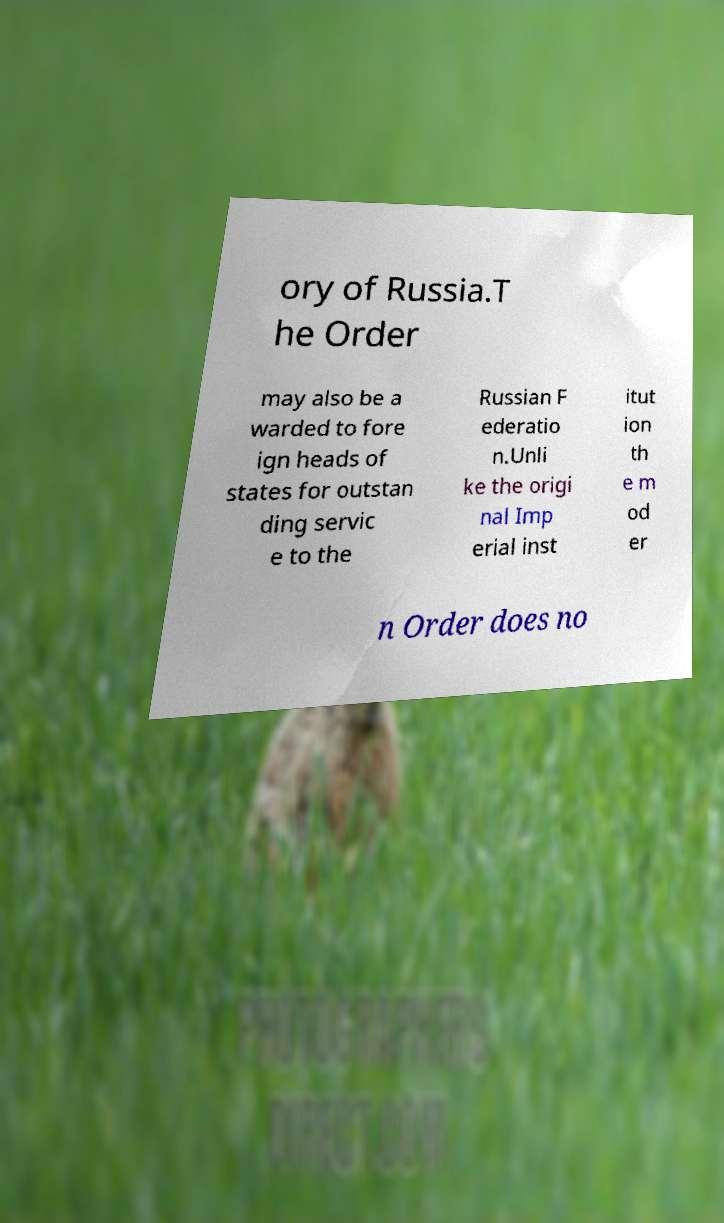Please identify and transcribe the text found in this image. ory of Russia.T he Order may also be a warded to fore ign heads of states for outstan ding servic e to the Russian F ederatio n.Unli ke the origi nal Imp erial inst itut ion th e m od er n Order does no 